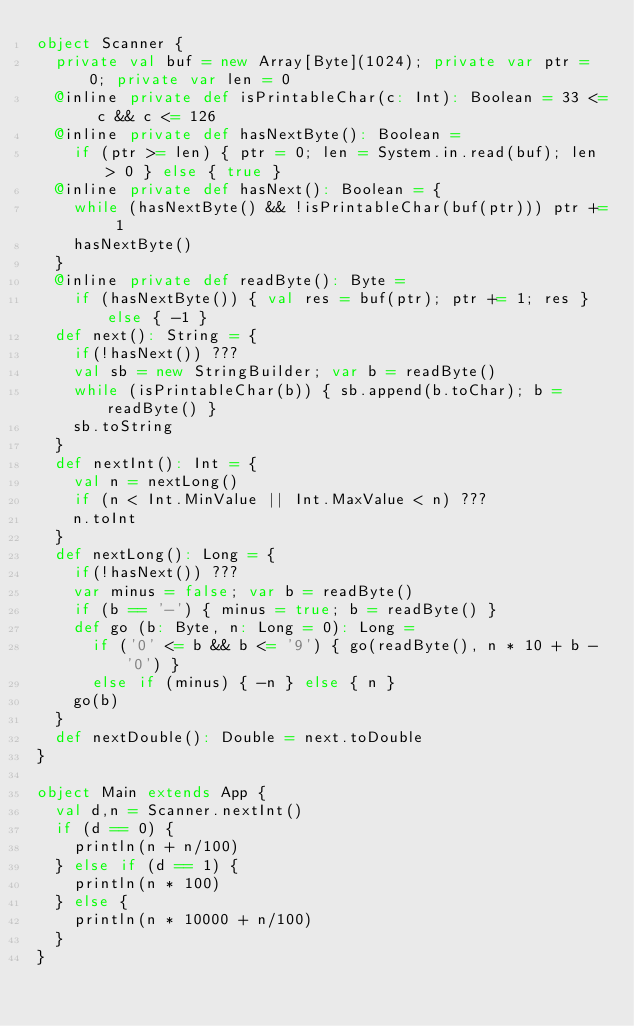Convert code to text. <code><loc_0><loc_0><loc_500><loc_500><_Scala_>object Scanner {
  private val buf = new Array[Byte](1024); private var ptr = 0; private var len = 0
  @inline private def isPrintableChar(c: Int): Boolean = 33 <= c && c <= 126
  @inline private def hasNextByte(): Boolean =
    if (ptr >= len) { ptr = 0; len = System.in.read(buf); len > 0 } else { true }
  @inline private def hasNext(): Boolean = {
    while (hasNextByte() && !isPrintableChar(buf(ptr))) ptr += 1
    hasNextByte()
  }
  @inline private def readByte(): Byte =
    if (hasNextByte()) { val res = buf(ptr); ptr += 1; res } else { -1 }
  def next(): String = {
    if(!hasNext()) ???
    val sb = new StringBuilder; var b = readByte()
    while (isPrintableChar(b)) { sb.append(b.toChar); b = readByte() }
    sb.toString
  }
  def nextInt(): Int = {
    val n = nextLong()
    if (n < Int.MinValue || Int.MaxValue < n) ???
    n.toInt
  }
  def nextLong(): Long = {
    if(!hasNext()) ???
    var minus = false; var b = readByte()
    if (b == '-') { minus = true; b = readByte() }
    def go (b: Byte, n: Long = 0): Long =
      if ('0' <= b && b <= '9') { go(readByte(), n * 10 + b - '0') }
      else if (minus) { -n } else { n }
    go(b)
  }
  def nextDouble(): Double = next.toDouble
}

object Main extends App {
  val d,n = Scanner.nextInt()
  if (d == 0) {
    println(n + n/100)
  } else if (d == 1) {
    println(n * 100)
  } else {
    println(n * 10000 + n/100)
  }
}</code> 